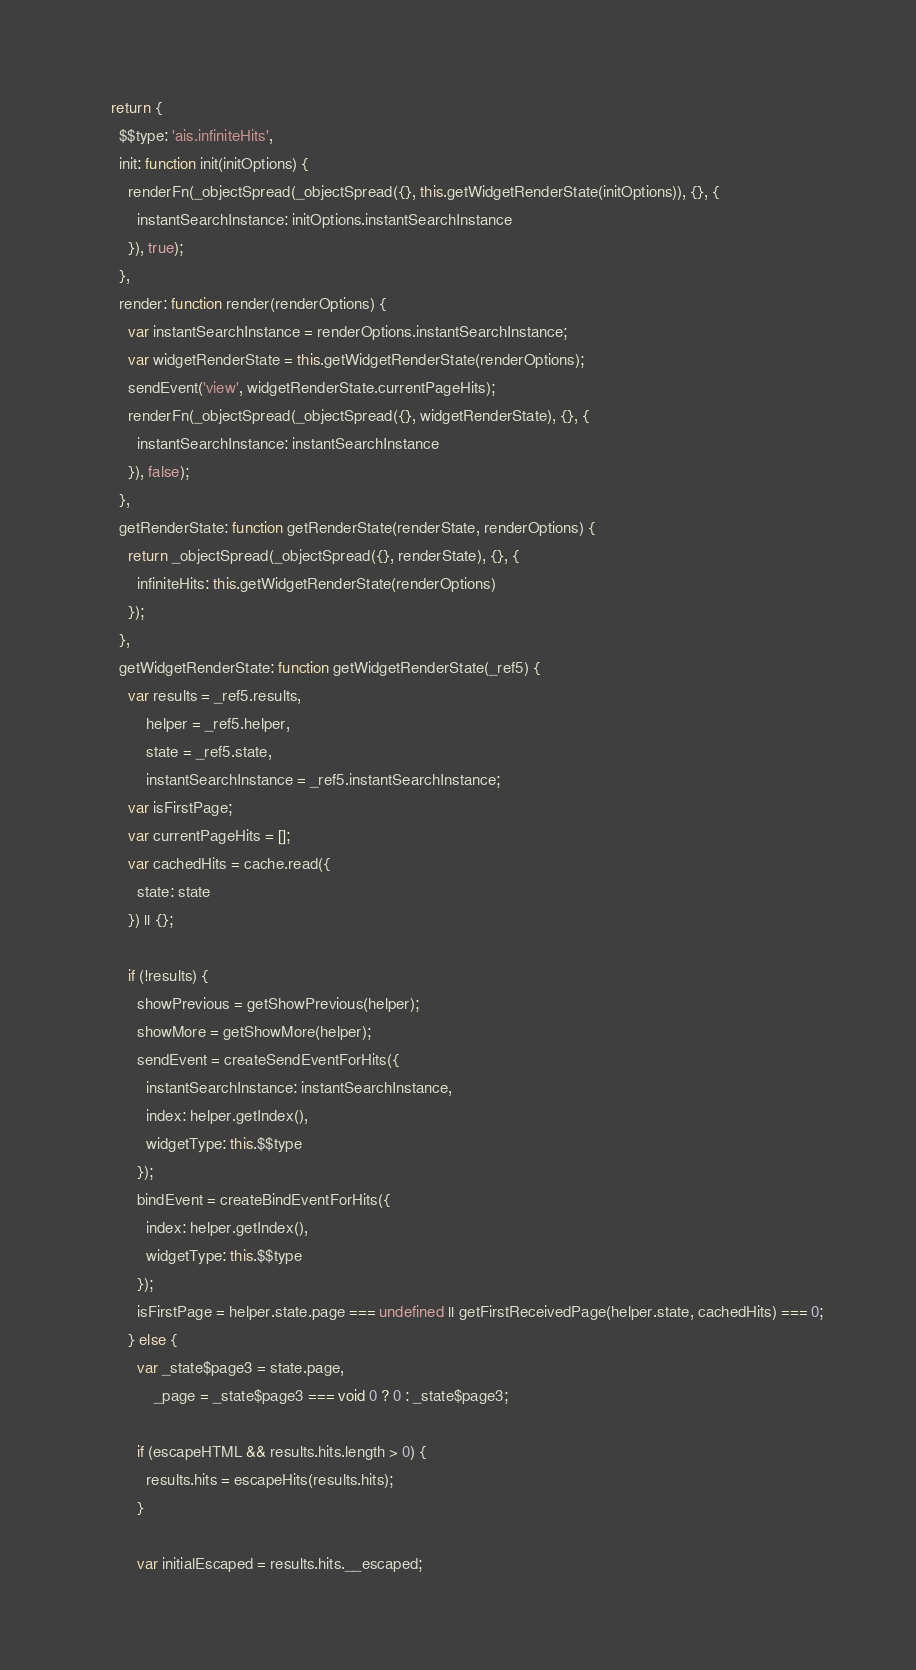Convert code to text. <code><loc_0><loc_0><loc_500><loc_500><_JavaScript_>
    return {
      $$type: 'ais.infiniteHits',
      init: function init(initOptions) {
        renderFn(_objectSpread(_objectSpread({}, this.getWidgetRenderState(initOptions)), {}, {
          instantSearchInstance: initOptions.instantSearchInstance
        }), true);
      },
      render: function render(renderOptions) {
        var instantSearchInstance = renderOptions.instantSearchInstance;
        var widgetRenderState = this.getWidgetRenderState(renderOptions);
        sendEvent('view', widgetRenderState.currentPageHits);
        renderFn(_objectSpread(_objectSpread({}, widgetRenderState), {}, {
          instantSearchInstance: instantSearchInstance
        }), false);
      },
      getRenderState: function getRenderState(renderState, renderOptions) {
        return _objectSpread(_objectSpread({}, renderState), {}, {
          infiniteHits: this.getWidgetRenderState(renderOptions)
        });
      },
      getWidgetRenderState: function getWidgetRenderState(_ref5) {
        var results = _ref5.results,
            helper = _ref5.helper,
            state = _ref5.state,
            instantSearchInstance = _ref5.instantSearchInstance;
        var isFirstPage;
        var currentPageHits = [];
        var cachedHits = cache.read({
          state: state
        }) || {};

        if (!results) {
          showPrevious = getShowPrevious(helper);
          showMore = getShowMore(helper);
          sendEvent = createSendEventForHits({
            instantSearchInstance: instantSearchInstance,
            index: helper.getIndex(),
            widgetType: this.$$type
          });
          bindEvent = createBindEventForHits({
            index: helper.getIndex(),
            widgetType: this.$$type
          });
          isFirstPage = helper.state.page === undefined || getFirstReceivedPage(helper.state, cachedHits) === 0;
        } else {
          var _state$page3 = state.page,
              _page = _state$page3 === void 0 ? 0 : _state$page3;

          if (escapeHTML && results.hits.length > 0) {
            results.hits = escapeHits(results.hits);
          }

          var initialEscaped = results.hits.__escaped;</code> 